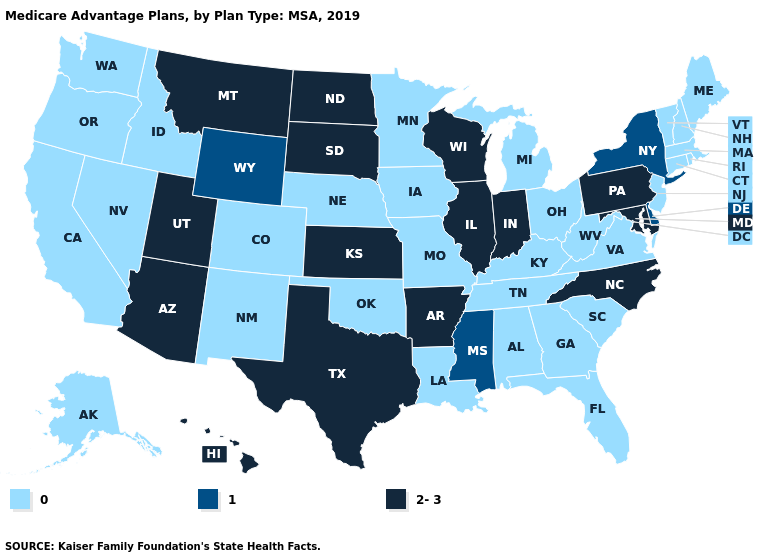Which states have the lowest value in the USA?
Keep it brief. Alabama, Alaska, California, Colorado, Connecticut, Florida, Georgia, Idaho, Iowa, Kentucky, Louisiana, Maine, Massachusetts, Michigan, Minnesota, Missouri, Nebraska, Nevada, New Hampshire, New Jersey, New Mexico, Ohio, Oklahoma, Oregon, Rhode Island, South Carolina, Tennessee, Vermont, Virginia, Washington, West Virginia. Does Colorado have the same value as Arizona?
Give a very brief answer. No. Name the states that have a value in the range 2-3?
Write a very short answer. Arizona, Arkansas, Hawaii, Illinois, Indiana, Kansas, Maryland, Montana, North Carolina, North Dakota, Pennsylvania, South Dakota, Texas, Utah, Wisconsin. Does Nebraska have the lowest value in the MidWest?
Quick response, please. Yes. What is the lowest value in states that border North Dakota?
Concise answer only. 0. What is the value of New York?
Short answer required. 1. Which states hav the highest value in the West?
Write a very short answer. Arizona, Hawaii, Montana, Utah. What is the value of Alaska?
Give a very brief answer. 0. Name the states that have a value in the range 0?
Be succinct. Alabama, Alaska, California, Colorado, Connecticut, Florida, Georgia, Idaho, Iowa, Kentucky, Louisiana, Maine, Massachusetts, Michigan, Minnesota, Missouri, Nebraska, Nevada, New Hampshire, New Jersey, New Mexico, Ohio, Oklahoma, Oregon, Rhode Island, South Carolina, Tennessee, Vermont, Virginia, Washington, West Virginia. What is the lowest value in the West?
Short answer required. 0. Which states hav the highest value in the MidWest?
Keep it brief. Illinois, Indiana, Kansas, North Dakota, South Dakota, Wisconsin. Name the states that have a value in the range 0?
Short answer required. Alabama, Alaska, California, Colorado, Connecticut, Florida, Georgia, Idaho, Iowa, Kentucky, Louisiana, Maine, Massachusetts, Michigan, Minnesota, Missouri, Nebraska, Nevada, New Hampshire, New Jersey, New Mexico, Ohio, Oklahoma, Oregon, Rhode Island, South Carolina, Tennessee, Vermont, Virginia, Washington, West Virginia. What is the value of Alabama?
Quick response, please. 0. Which states have the highest value in the USA?
Concise answer only. Arizona, Arkansas, Hawaii, Illinois, Indiana, Kansas, Maryland, Montana, North Carolina, North Dakota, Pennsylvania, South Dakota, Texas, Utah, Wisconsin. Name the states that have a value in the range 2-3?
Write a very short answer. Arizona, Arkansas, Hawaii, Illinois, Indiana, Kansas, Maryland, Montana, North Carolina, North Dakota, Pennsylvania, South Dakota, Texas, Utah, Wisconsin. 